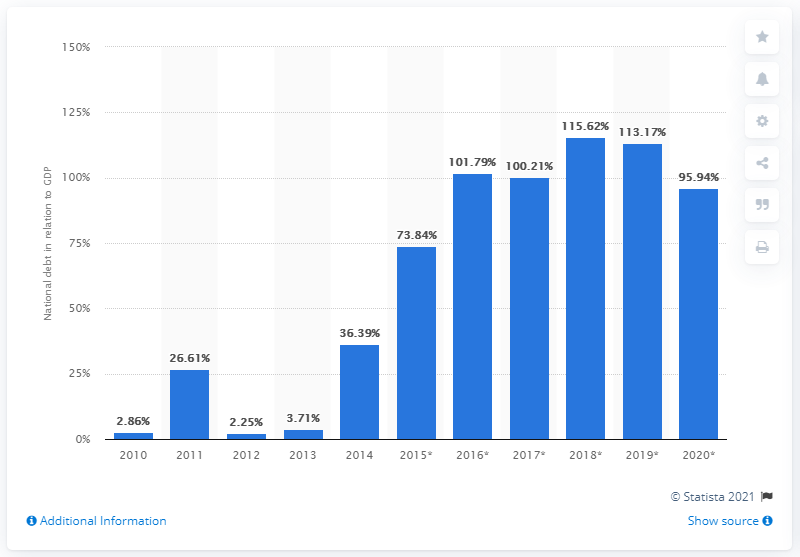Indicate a few pertinent items in this graphic. In 2014, the national debt of Libya comprised 36.39% of the country's Gross Domestic Product (GDP), a significant portion of the overall economy. 